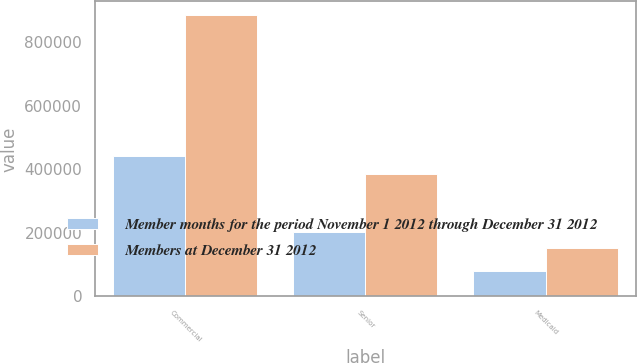Convert chart. <chart><loc_0><loc_0><loc_500><loc_500><stacked_bar_chart><ecel><fcel>Commercial<fcel>Senior<fcel>Medicaid<nl><fcel>Member months for the period November 1 2012 through December 31 2012<fcel>442700<fcel>201300<fcel>80000<nl><fcel>Members at December 31 2012<fcel>885200<fcel>385300<fcel>152100<nl></chart> 